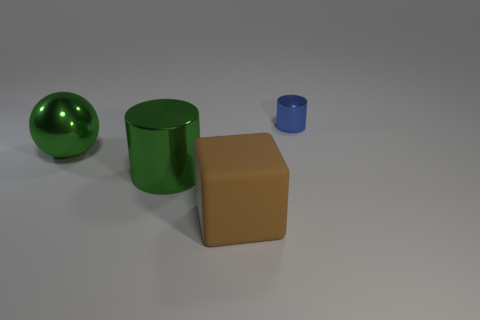There is a thing that is the same color as the sphere; what is its shape?
Keep it short and to the point. Cylinder. How many rubber objects are either green things or big brown objects?
Your answer should be very brief. 1. There is a large shiny thing that is on the right side of the shiny thing on the left side of the cylinder that is to the left of the tiny blue metallic cylinder; what color is it?
Ensure brevity in your answer.  Green. There is another object that is the same shape as the blue thing; what is its color?
Give a very brief answer. Green. Are there any other things that are the same color as the big metal sphere?
Your response must be concise. Yes. What number of other things are there of the same material as the tiny cylinder
Keep it short and to the point. 2. How big is the matte block?
Your answer should be compact. Large. Are there any other things of the same shape as the small blue thing?
Give a very brief answer. Yes. What number of objects are either tiny yellow things or large things behind the big green metallic cylinder?
Your answer should be compact. 1. The big object to the left of the big green cylinder is what color?
Offer a very short reply. Green. 